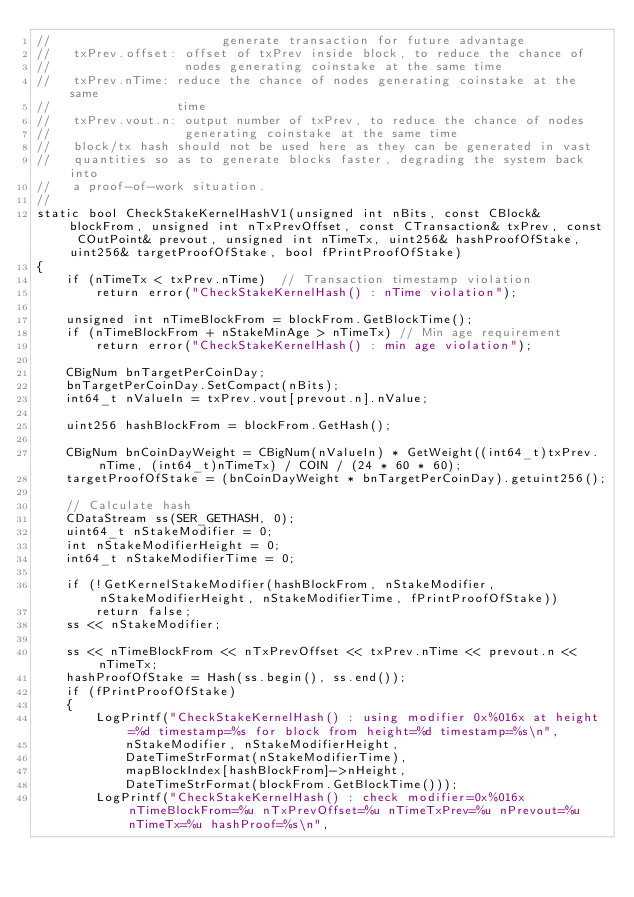Convert code to text. <code><loc_0><loc_0><loc_500><loc_500><_C++_>//                       generate transaction for future advantage
//   txPrev.offset: offset of txPrev inside block, to reduce the chance of 
//                  nodes generating coinstake at the same time
//   txPrev.nTime: reduce the chance of nodes generating coinstake at the same
//                 time
//   txPrev.vout.n: output number of txPrev, to reduce the chance of nodes
//                  generating coinstake at the same time
//   block/tx hash should not be used here as they can be generated in vast
//   quantities so as to generate blocks faster, degrading the system back into
//   a proof-of-work situation.
//
static bool CheckStakeKernelHashV1(unsigned int nBits, const CBlock& blockFrom, unsigned int nTxPrevOffset, const CTransaction& txPrev, const COutPoint& prevout, unsigned int nTimeTx, uint256& hashProofOfStake, uint256& targetProofOfStake, bool fPrintProofOfStake)
{
    if (nTimeTx < txPrev.nTime)  // Transaction timestamp violation
        return error("CheckStakeKernelHash() : nTime violation");

    unsigned int nTimeBlockFrom = blockFrom.GetBlockTime();
    if (nTimeBlockFrom + nStakeMinAge > nTimeTx) // Min age requirement
        return error("CheckStakeKernelHash() : min age violation");

    CBigNum bnTargetPerCoinDay;
    bnTargetPerCoinDay.SetCompact(nBits);
    int64_t nValueIn = txPrev.vout[prevout.n].nValue;

    uint256 hashBlockFrom = blockFrom.GetHash();

    CBigNum bnCoinDayWeight = CBigNum(nValueIn) * GetWeight((int64_t)txPrev.nTime, (int64_t)nTimeTx) / COIN / (24 * 60 * 60);
    targetProofOfStake = (bnCoinDayWeight * bnTargetPerCoinDay).getuint256();

    // Calculate hash
    CDataStream ss(SER_GETHASH, 0);
    uint64_t nStakeModifier = 0;
    int nStakeModifierHeight = 0;
    int64_t nStakeModifierTime = 0;

    if (!GetKernelStakeModifier(hashBlockFrom, nStakeModifier, nStakeModifierHeight, nStakeModifierTime, fPrintProofOfStake))
        return false;
    ss << nStakeModifier;

    ss << nTimeBlockFrom << nTxPrevOffset << txPrev.nTime << prevout.n << nTimeTx;
    hashProofOfStake = Hash(ss.begin(), ss.end());
    if (fPrintProofOfStake)
    {
        LogPrintf("CheckStakeKernelHash() : using modifier 0x%016x at height=%d timestamp=%s for block from height=%d timestamp=%s\n",
            nStakeModifier, nStakeModifierHeight,
            DateTimeStrFormat(nStakeModifierTime),
            mapBlockIndex[hashBlockFrom]->nHeight,
            DateTimeStrFormat(blockFrom.GetBlockTime()));
        LogPrintf("CheckStakeKernelHash() : check modifier=0x%016x nTimeBlockFrom=%u nTxPrevOffset=%u nTimeTxPrev=%u nPrevout=%u nTimeTx=%u hashProof=%s\n",</code> 